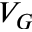Convert formula to latex. <formula><loc_0><loc_0><loc_500><loc_500>V _ { G }</formula> 